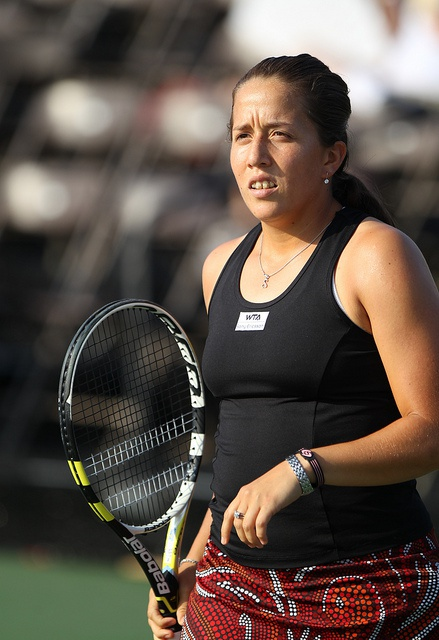Describe the objects in this image and their specific colors. I can see people in black, maroon, and tan tones and tennis racket in black, gray, ivory, and darkgray tones in this image. 